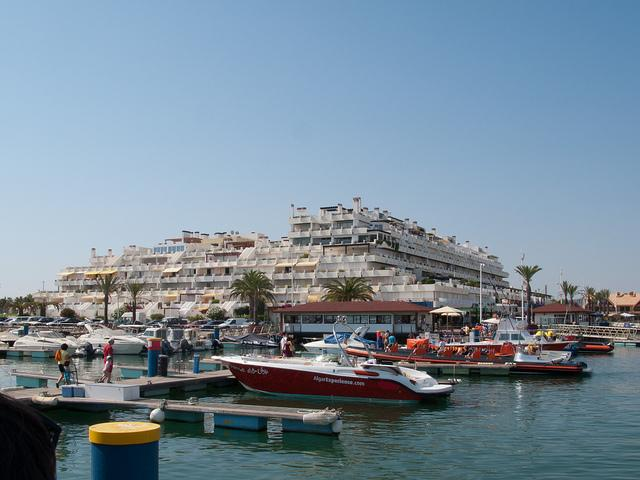What does the side of the nearest boat want you to visit?

Choices:
A) website
B) brazil
C) japan
D) restaurant website 